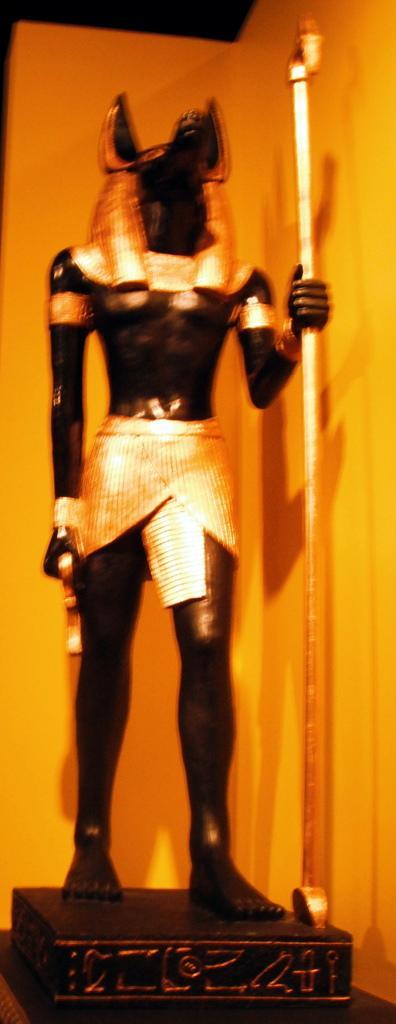In one or two sentences, can you explain what this image depicts? In this image I can see a black colour sculpture and I can see this image is little bit blurry. I can also see this sculpture is holding a rod. 